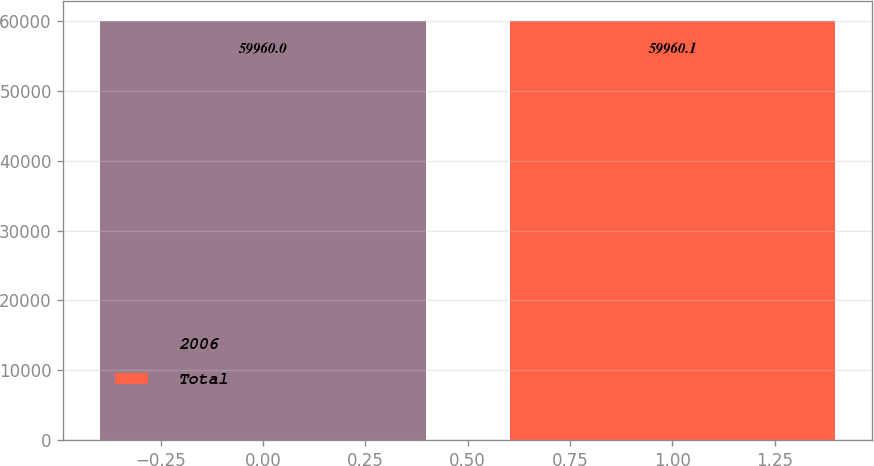Convert chart. <chart><loc_0><loc_0><loc_500><loc_500><bar_chart><fcel>2006<fcel>Total<nl><fcel>59960<fcel>59960.1<nl></chart> 